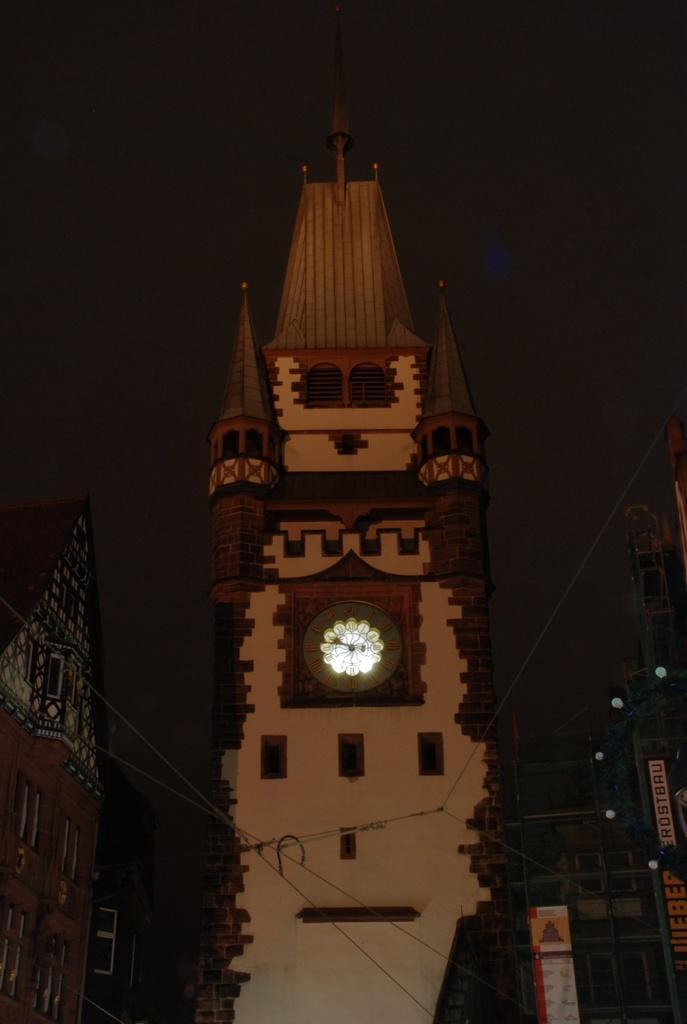How would you summarize this image in a sentence or two? In this picture we can see tall clock tower in the front. Beside we can see some buildings. Behind there is a dark background. 